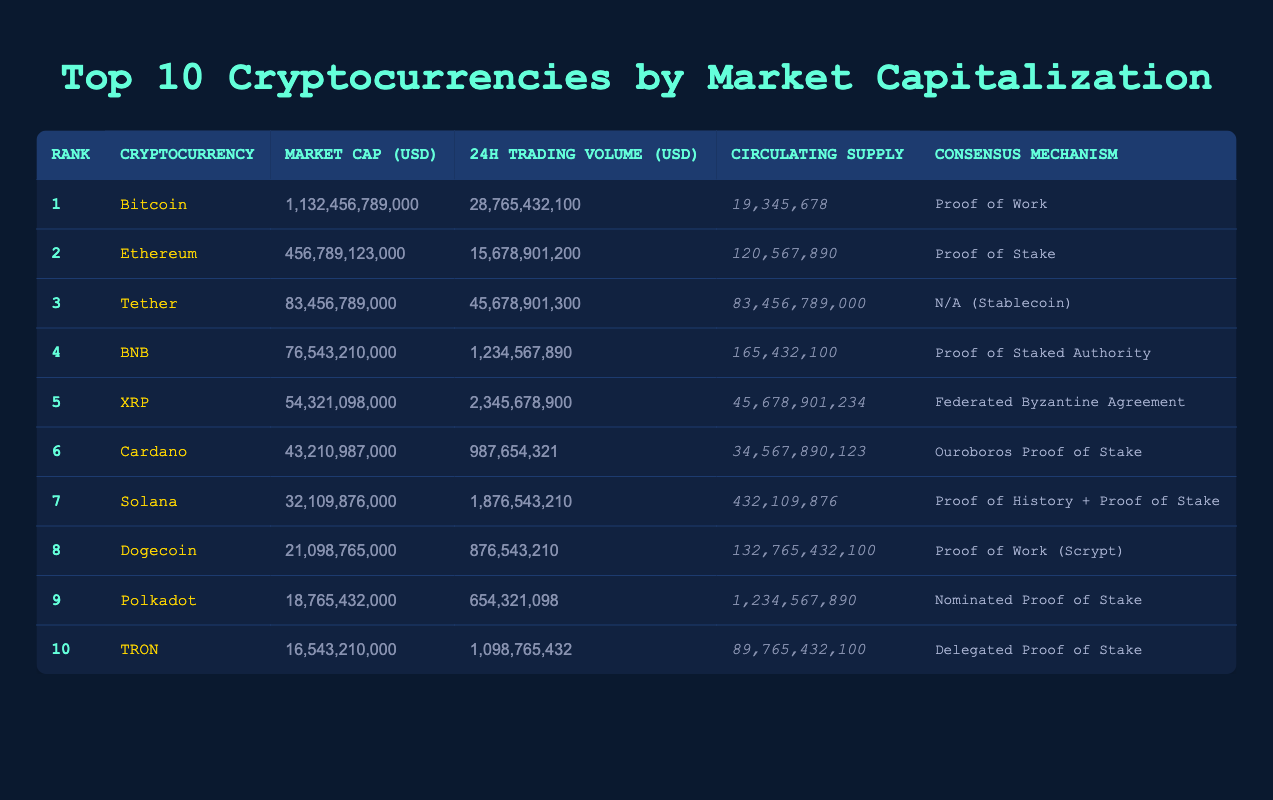What is the market cap of Bitcoin? The market cap of Bitcoin is listed in the table under the "Market Cap (USD)" column for the row with Rank 1. The value is 1,132,456,789,000.
Answer: 1,132,456,789,000 Which cryptocurrency has the highest 24h trading volume? In the table, the "24h Trading Volume (USD)" column indicates the trading volumes for each cryptocurrency. Tether, ranked 3, has a trading volume of 45,678,901,300, which is the highest among all listed.
Answer: Tether What is the total market cap of the top three cryptocurrencies? To find the total market cap, sum the market cap values of Bitcoin, Ethereum, and Tether: 1,132,456,789,000 + 456,789,123,000 + 83,456,789,000 = 1,672,702,701,000.
Answer: 1,672,702,701,000 Is Dogecoin's circulating supply greater than 100 billion? The circulating supply of Dogecoin is listed in the table as 132,765,432,100. Since 132,765,432,100 is greater than 100 billion, the answer is yes.
Answer: Yes Which consensus mechanism is used by Cardano? According to the table, the consensus mechanism for Cardano, listed under the "Consensus Mechanism" column in the row for Rank 6, is Ouroboros Proof of Stake.
Answer: Ouroboros Proof of Stake How many cryptocurrencies use Proof of Work as their consensus mechanism? The table shows that Bitcoin and Dogecoin use Proof of Work (noted in their respective rows). Thus, there are 2 cryptocurrencies using this mechanism.
Answer: 2 What is the difference in market cap between BNB and XRP? The market cap of BNB is 76,543,210,000, and that of XRP is 54,321,098,000. The difference is obtained by subtracting XRP's market cap from BNB's: 76,543,210,000 - 54,321,098,000 = 22,222,112,000.
Answer: 22,222,112,000 What is the average circulating supply of the top ten cryptocurrencies? To calculate the average, first sum the circulating supply values: 19,345,678 + 120,567,890 + 83,456,789,000 + 165,432,100 + 45,678,901,234 + 34,567,890,123 + 432,109,876 + 132,765,432,100 + 1,234,567,890 + 89,765,432,100 = 373,855,291,100. Then divide by the number of cryptocurrencies, which is 10: 373,855,291,100 / 10 = 37,385,529,110.
Answer: 37,385,529,110 Does TRON have a higher market cap than Polkadot? The market cap for TRON is 16,543,210,000, and for Polkadot, it is 18,765,432,000. Since 16,543,210,000 is less than 18,765,432,000, the answer is no.
Answer: No 